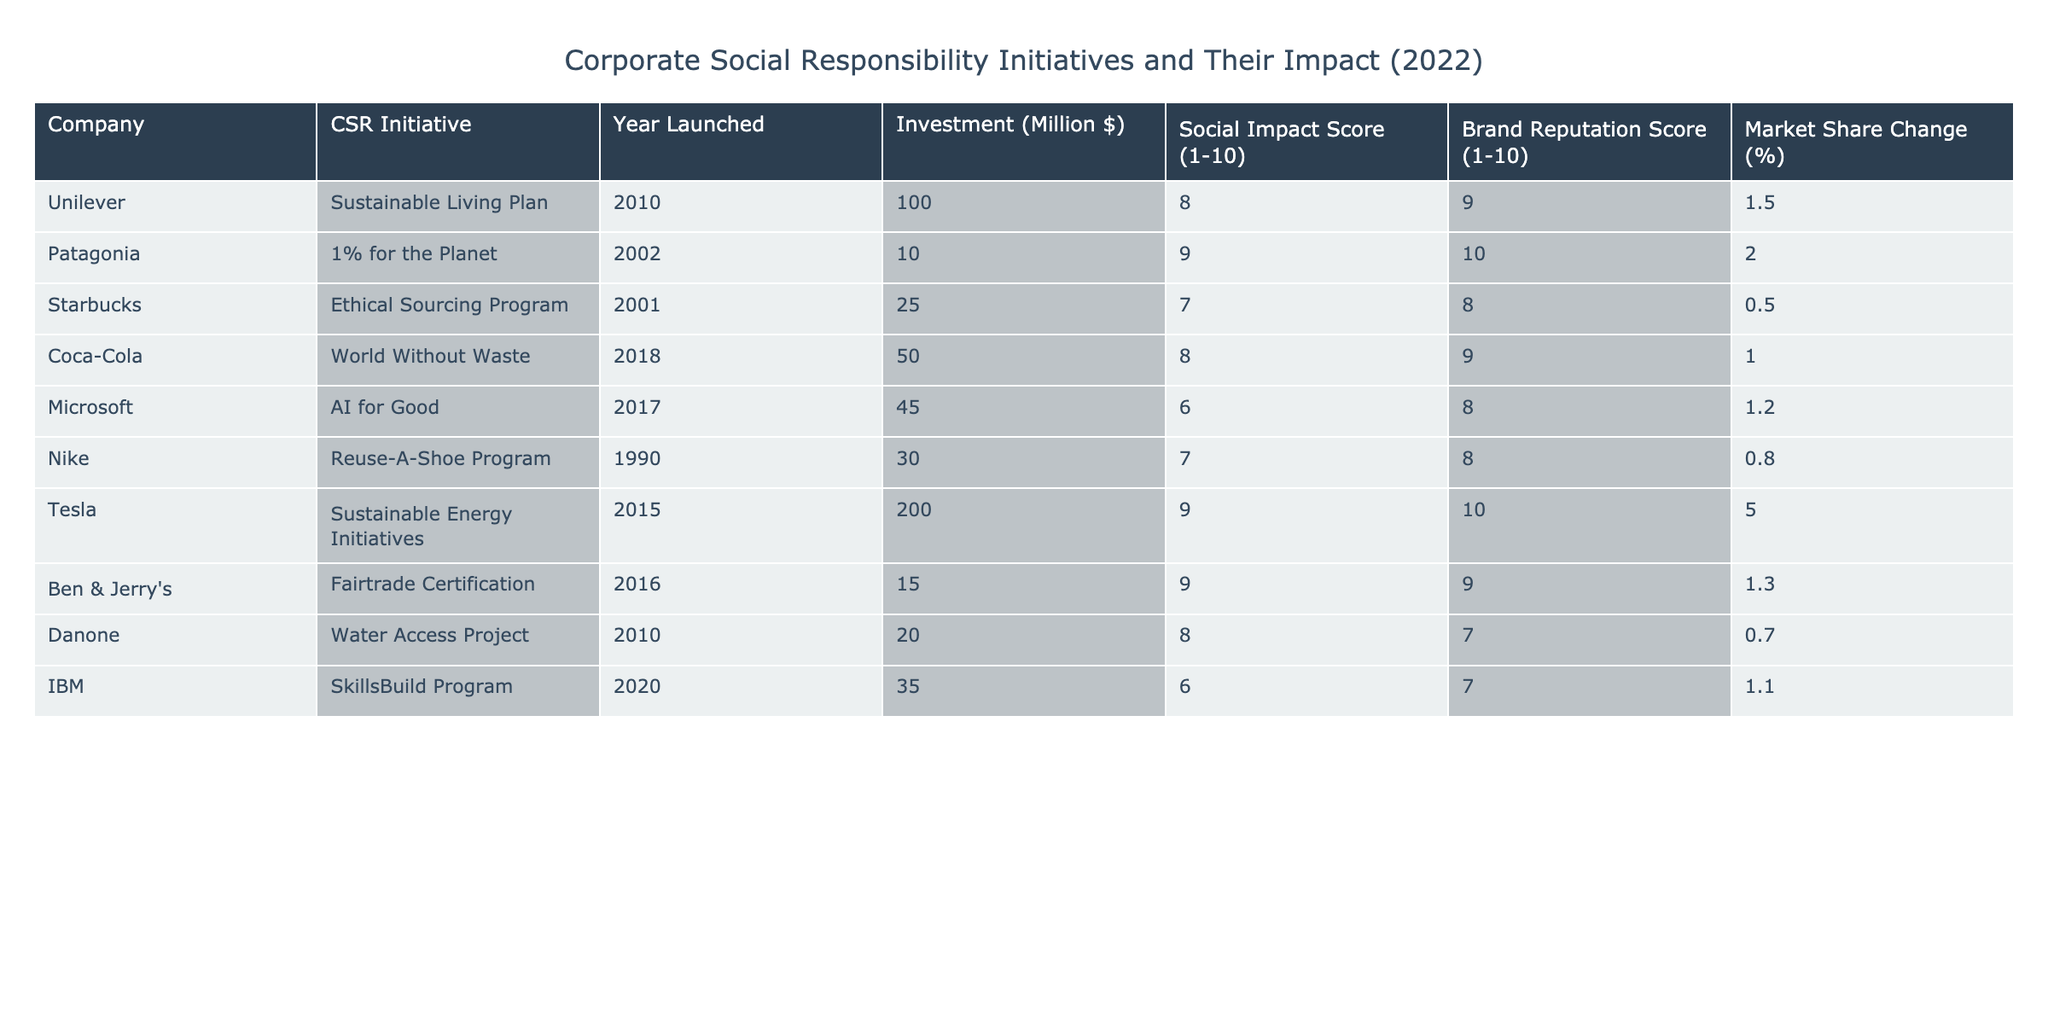What is the social impact score of Patagonia's CSR initiative? The table shows that Patagonia's CSR initiative, "1% for the Planet," has a social impact score of 9.
Answer: 9 Which company has the highest brand reputation score? By scanning the brand reputation scores, we find both Patagonia and Tesla have a score of 10, which is the highest.
Answer: Patagonia and Tesla What is the average investment of all companies listed in the table? To calculate the average investment, sum all investments: 100 + 10 + 25 + 50 + 45 + 30 + 200 + 15 + 20 + 35 = 525. There are 10 companies, so average investment = 525/10 = 52.5 million dollars.
Answer: 52.5 million dollars Does Coca-Cola have a higher social impact score than Nike? Coca-Cola's social impact score is 8, while Nike's is 7. Since 8 is higher than 7, the answer is yes.
Answer: Yes What is the total market share change percentage for companies with a brand reputation score of at least 9? The companies with a brand reputation score of at least 9 are Patagonia (2.0), Coca-Cola (1.0), Tesla (5.0), and Ben & Jerry's (1.3). Adding these percentages gives: 2.0 + 1.0 + 5.0 + 1.3 = 9.3%.
Answer: 9.3% Does Microsoft have the lowest social impact score among the companies listed? Microsoft has a social impact score of 6, and by comparing it with all the others, the lowest score is indeed 6, which belongs to Microsoft. Therefore, the answer is yes.
Answer: Yes What is the difference in brand reputation score between Unilever and Tesla? Unilever has a brand reputation score of 9, while Tesla has a score of 10. The difference is 10 - 9 = 1.
Answer: 1 Which company increased its market share the most, and by how much? By comparing the market share changes, Tesla has the largest increase of 5.0%.
Answer: Tesla, 5.0% 